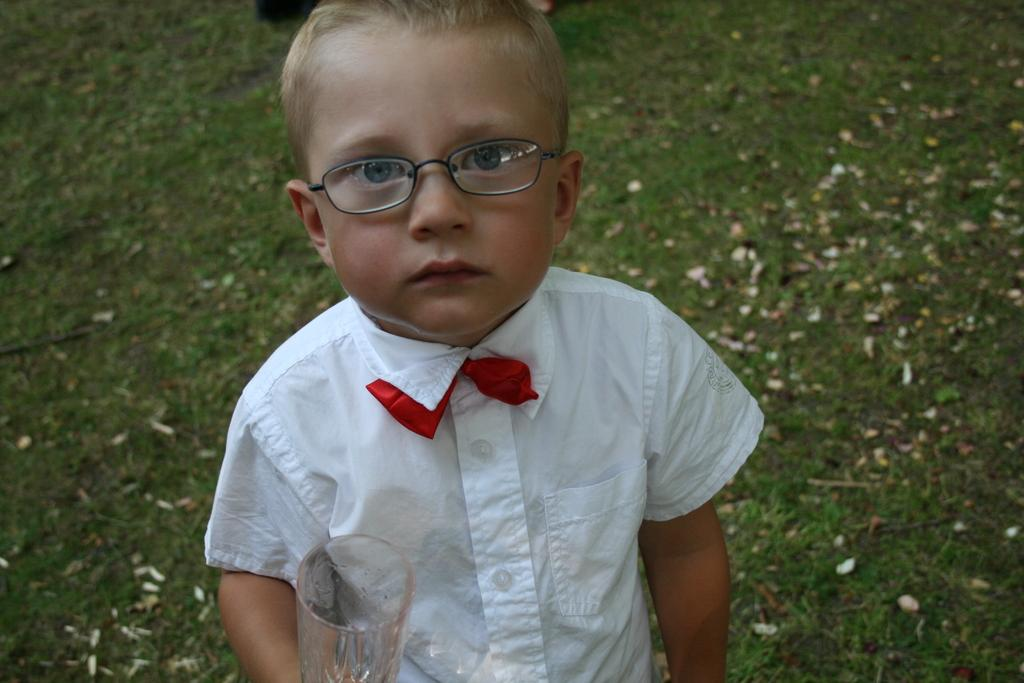Who is the main subject in the picture? There is a boy in the picture. What is the boy standing on? The boy is standing on a grass surface. What is the boy holding in his hand? The boy is holding a glass. What is the boy wearing on his upper body? The boy is wearing a white shirt and a red color tie. How many girls are present in the image? There are no girls present in the image; it features a boy. What type of powder is being used by the visitor in the image? There is no visitor or powder present in the image. 